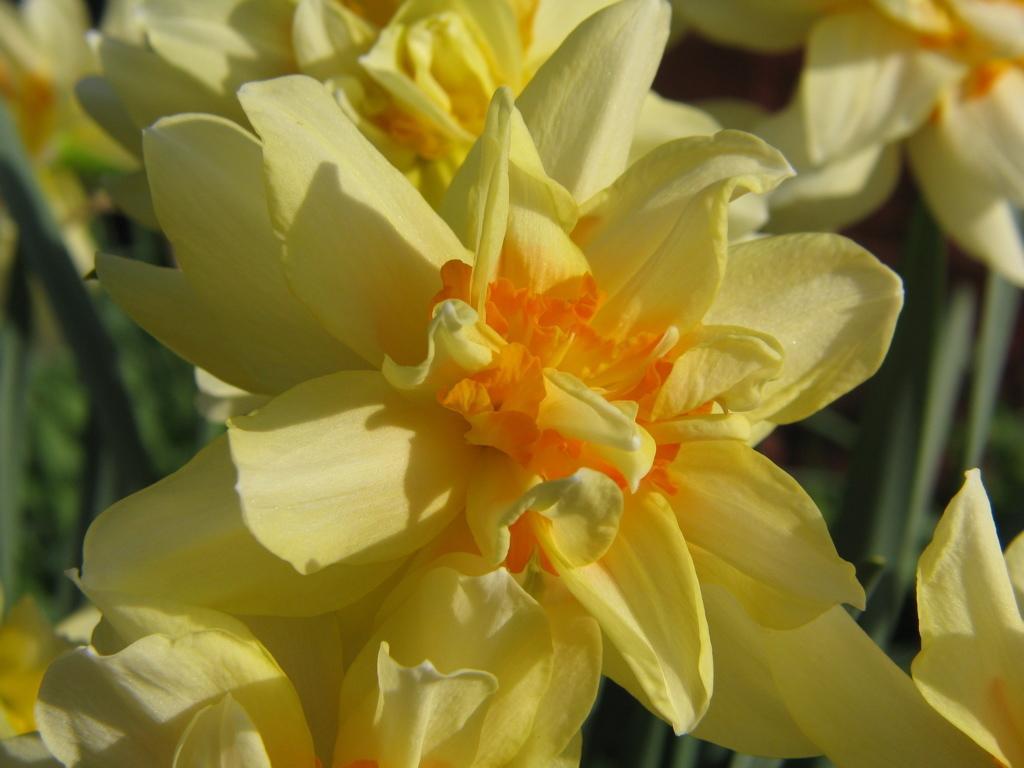Can you describe this image briefly? In the center of the image we can see flowers which are in yellow color. 